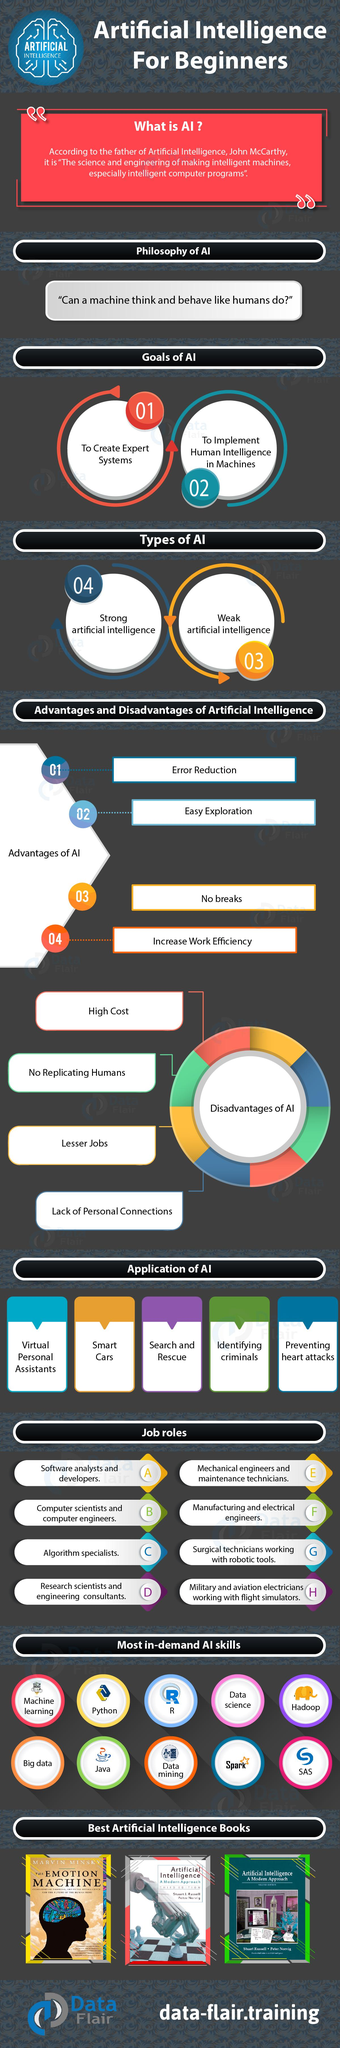Identify some key points in this picture. There are three books on artificial intelligence that are currently being displayed. Artificial intelligence is the science of creating intelligent machines and computer programs that can perform tasks normally requiring human intelligence, such as understanding natural language, recognizing objects, and making decisions. It is clear that humans possess the ability to form stronger and more meaningful personal connections than AI technology. The author of "The Emotion Machine" is Marvin Minsky. There are five mentions of artificial intelligence in this text. 